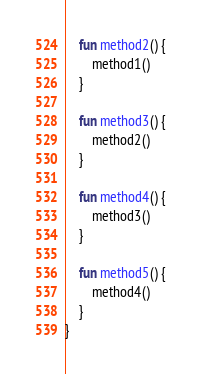<code> <loc_0><loc_0><loc_500><loc_500><_Kotlin_>    fun method2() {
        method1()
    }

    fun method3() {
        method2()
    }

    fun method4() {
        method3()
    }

    fun method5() {
        method4()
    }
}
</code> 